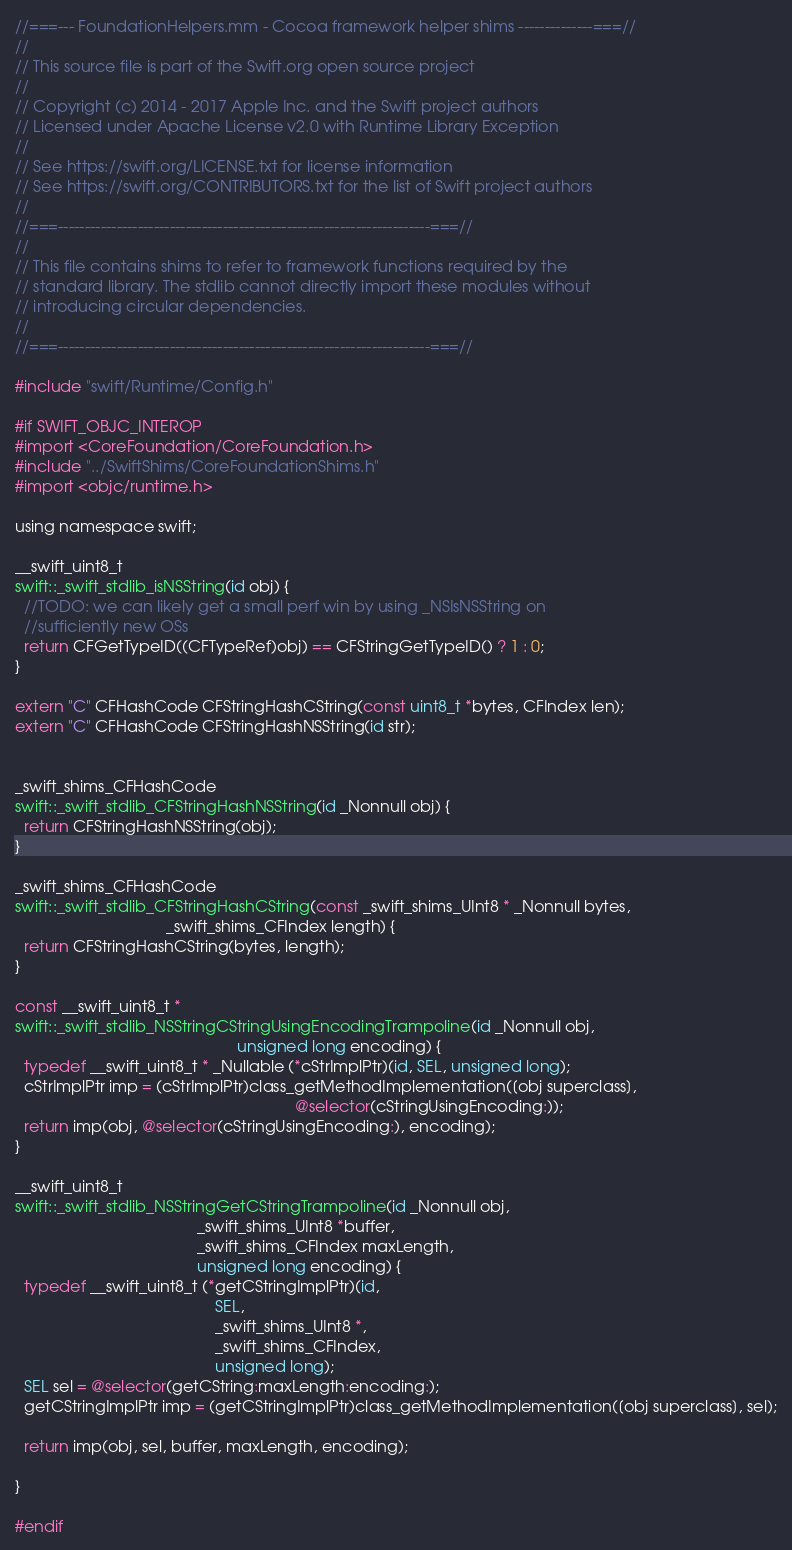<code> <loc_0><loc_0><loc_500><loc_500><_ObjectiveC_>//===--- FoundationHelpers.mm - Cocoa framework helper shims --------------===//
//
// This source file is part of the Swift.org open source project
//
// Copyright (c) 2014 - 2017 Apple Inc. and the Swift project authors
// Licensed under Apache License v2.0 with Runtime Library Exception
//
// See https://swift.org/LICENSE.txt for license information
// See https://swift.org/CONTRIBUTORS.txt for the list of Swift project authors
//
//===----------------------------------------------------------------------===//
//
// This file contains shims to refer to framework functions required by the
// standard library. The stdlib cannot directly import these modules without
// introducing circular dependencies.
//
//===----------------------------------------------------------------------===//

#include "swift/Runtime/Config.h"

#if SWIFT_OBJC_INTEROP
#import <CoreFoundation/CoreFoundation.h>
#include "../SwiftShims/CoreFoundationShims.h"
#import <objc/runtime.h>

using namespace swift;

__swift_uint8_t
swift::_swift_stdlib_isNSString(id obj) {
  //TODO: we can likely get a small perf win by using _NSIsNSString on
  //sufficiently new OSs
  return CFGetTypeID((CFTypeRef)obj) == CFStringGetTypeID() ? 1 : 0;
}

extern "C" CFHashCode CFStringHashCString(const uint8_t *bytes, CFIndex len);
extern "C" CFHashCode CFStringHashNSString(id str);


_swift_shims_CFHashCode
swift::_swift_stdlib_CFStringHashNSString(id _Nonnull obj) {
  return CFStringHashNSString(obj);
}

_swift_shims_CFHashCode
swift::_swift_stdlib_CFStringHashCString(const _swift_shims_UInt8 * _Nonnull bytes,
                                  _swift_shims_CFIndex length) {
  return CFStringHashCString(bytes, length);
}

const __swift_uint8_t *
swift::_swift_stdlib_NSStringCStringUsingEncodingTrampoline(id _Nonnull obj,
                                                  unsigned long encoding) {
  typedef __swift_uint8_t * _Nullable (*cStrImplPtr)(id, SEL, unsigned long);
  cStrImplPtr imp = (cStrImplPtr)class_getMethodImplementation([obj superclass],
                                                               @selector(cStringUsingEncoding:));
  return imp(obj, @selector(cStringUsingEncoding:), encoding);
}

__swift_uint8_t
swift::_swift_stdlib_NSStringGetCStringTrampoline(id _Nonnull obj,
                                         _swift_shims_UInt8 *buffer,
                                         _swift_shims_CFIndex maxLength,
                                         unsigned long encoding) {
  typedef __swift_uint8_t (*getCStringImplPtr)(id,
                                             SEL,
                                             _swift_shims_UInt8 *,
                                             _swift_shims_CFIndex,
                                             unsigned long);
  SEL sel = @selector(getCString:maxLength:encoding:);
  getCStringImplPtr imp = (getCStringImplPtr)class_getMethodImplementation([obj superclass], sel);
  
  return imp(obj, sel, buffer, maxLength, encoding);

}

#endif

</code> 